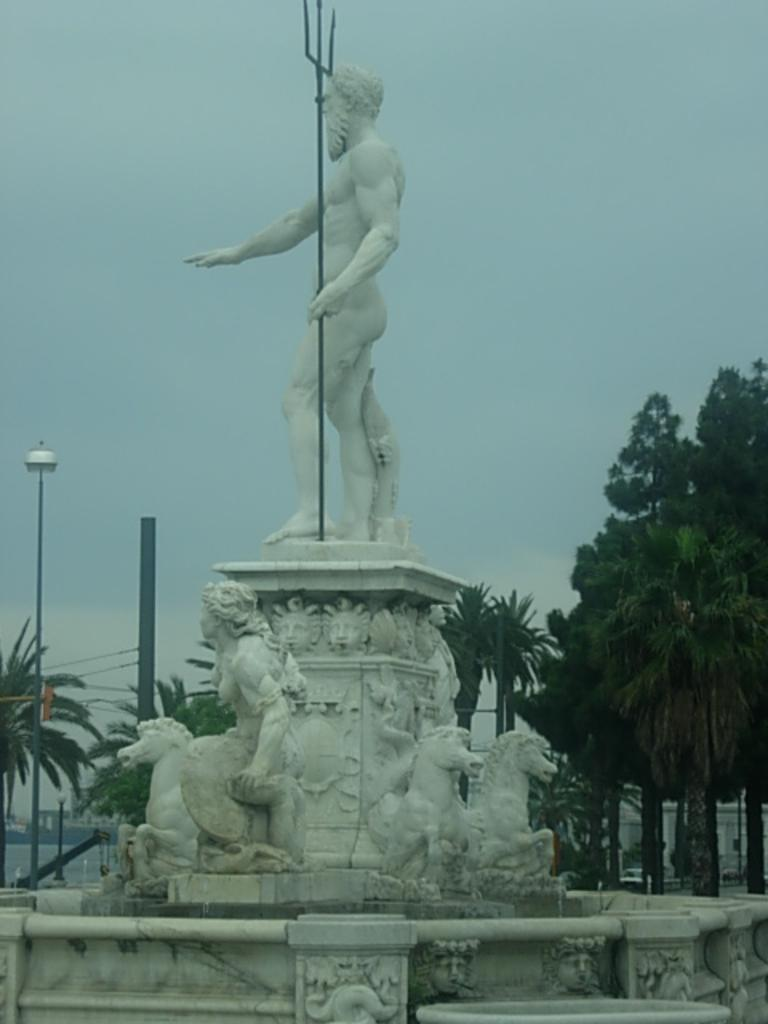What is the main subject of the image? There is a sculpture in the image. What type of natural elements can be seen in the image? There are trees in the image. What type of man-made structure is present in the image? There is a wall in the image. What is visible in the background of the image? The sky is visible in the image. What type of animal is wearing a mitten in the image? There is no animal wearing a mitten present in the image. What type of work is being done by the person in the image? There is no person performing any work in the image; it features a sculpture, trees, a wall, and the sky. 